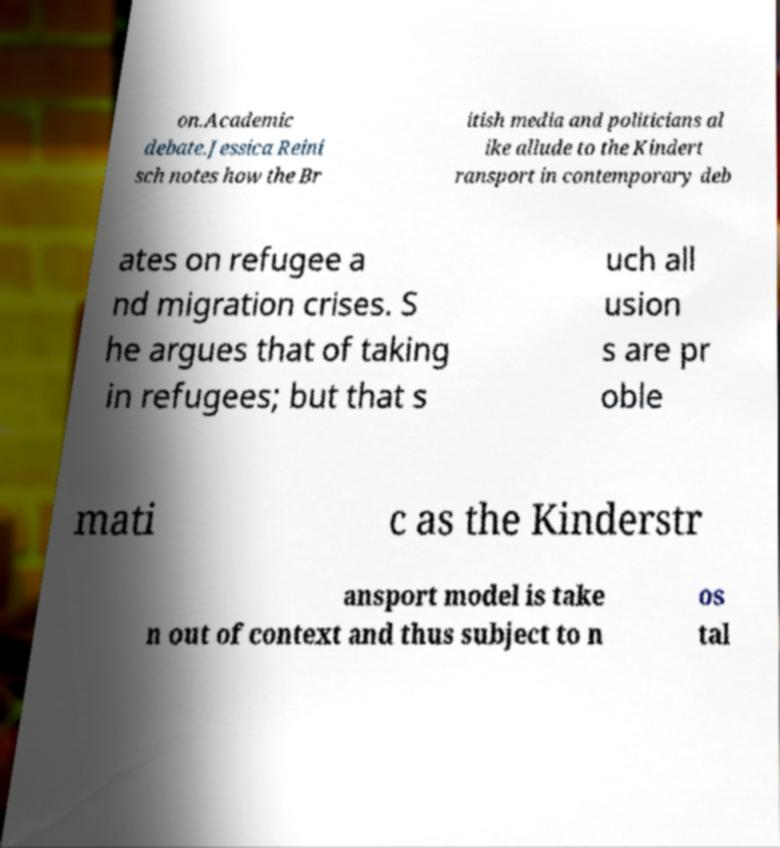For documentation purposes, I need the text within this image transcribed. Could you provide that? on.Academic debate.Jessica Reini sch notes how the Br itish media and politicians al ike allude to the Kindert ransport in contemporary deb ates on refugee a nd migration crises. S he argues that of taking in refugees; but that s uch all usion s are pr oble mati c as the Kinderstr ansport model is take n out of context and thus subject to n os tal 